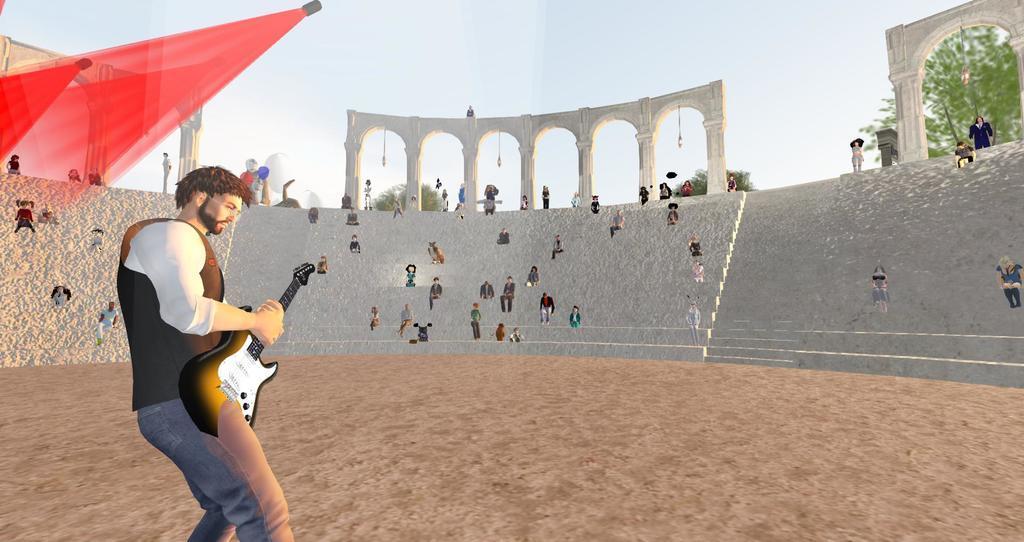In one or two sentences, can you explain what this image depicts? This looks like an animated image. I can see a person standing and playing the guitar. There are few people sitting and few people standing. At the top of the image, I can see the show lights. Behind the stairs, I can see the trees. 